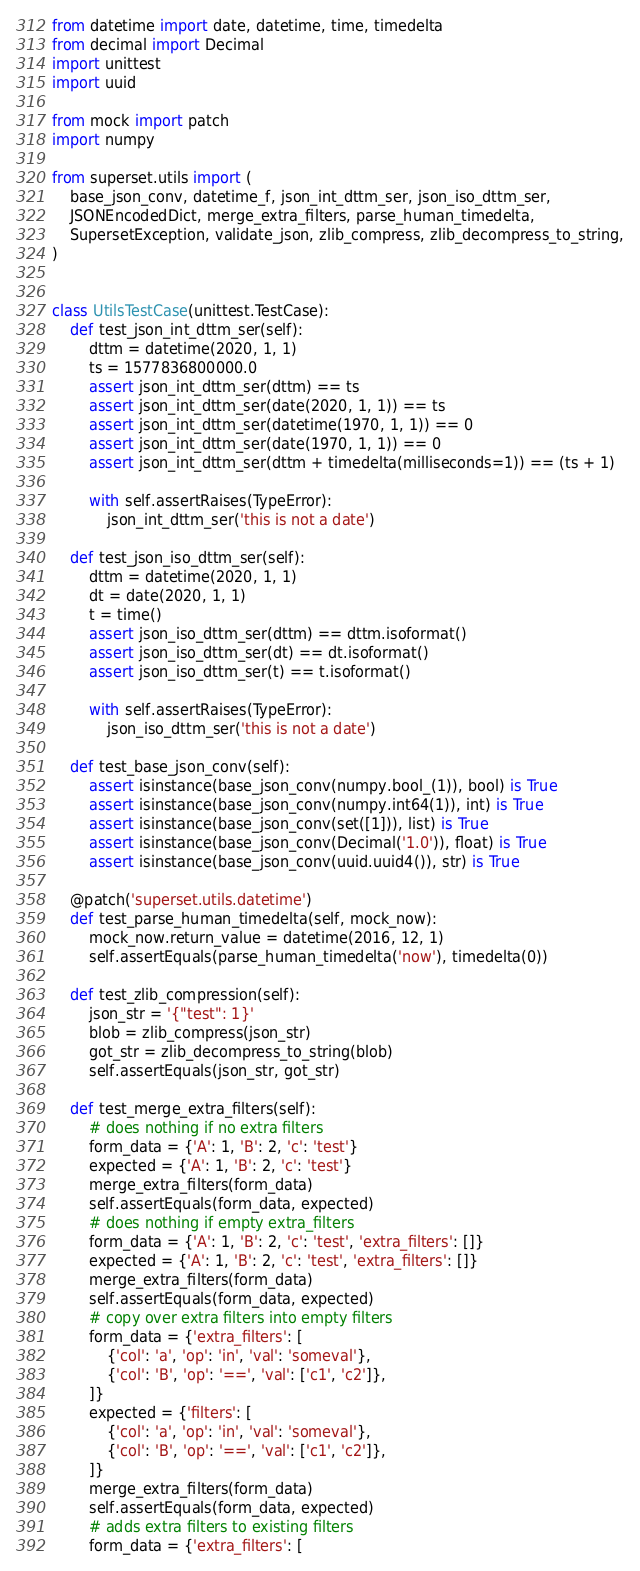Convert code to text. <code><loc_0><loc_0><loc_500><loc_500><_Python_>from datetime import date, datetime, time, timedelta
from decimal import Decimal
import unittest
import uuid

from mock import patch
import numpy

from superset.utils import (
    base_json_conv, datetime_f, json_int_dttm_ser, json_iso_dttm_ser,
    JSONEncodedDict, merge_extra_filters, parse_human_timedelta,
    SupersetException, validate_json, zlib_compress, zlib_decompress_to_string,
)


class UtilsTestCase(unittest.TestCase):
    def test_json_int_dttm_ser(self):
        dttm = datetime(2020, 1, 1)
        ts = 1577836800000.0
        assert json_int_dttm_ser(dttm) == ts
        assert json_int_dttm_ser(date(2020, 1, 1)) == ts
        assert json_int_dttm_ser(datetime(1970, 1, 1)) == 0
        assert json_int_dttm_ser(date(1970, 1, 1)) == 0
        assert json_int_dttm_ser(dttm + timedelta(milliseconds=1)) == (ts + 1)

        with self.assertRaises(TypeError):
            json_int_dttm_ser('this is not a date')

    def test_json_iso_dttm_ser(self):
        dttm = datetime(2020, 1, 1)
        dt = date(2020, 1, 1)
        t = time()
        assert json_iso_dttm_ser(dttm) == dttm.isoformat()
        assert json_iso_dttm_ser(dt) == dt.isoformat()
        assert json_iso_dttm_ser(t) == t.isoformat()

        with self.assertRaises(TypeError):
            json_iso_dttm_ser('this is not a date')

    def test_base_json_conv(self):
        assert isinstance(base_json_conv(numpy.bool_(1)), bool) is True
        assert isinstance(base_json_conv(numpy.int64(1)), int) is True
        assert isinstance(base_json_conv(set([1])), list) is True
        assert isinstance(base_json_conv(Decimal('1.0')), float) is True
        assert isinstance(base_json_conv(uuid.uuid4()), str) is True

    @patch('superset.utils.datetime')
    def test_parse_human_timedelta(self, mock_now):
        mock_now.return_value = datetime(2016, 12, 1)
        self.assertEquals(parse_human_timedelta('now'), timedelta(0))

    def test_zlib_compression(self):
        json_str = '{"test": 1}'
        blob = zlib_compress(json_str)
        got_str = zlib_decompress_to_string(blob)
        self.assertEquals(json_str, got_str)

    def test_merge_extra_filters(self):
        # does nothing if no extra filters
        form_data = {'A': 1, 'B': 2, 'c': 'test'}
        expected = {'A': 1, 'B': 2, 'c': 'test'}
        merge_extra_filters(form_data)
        self.assertEquals(form_data, expected)
        # does nothing if empty extra_filters
        form_data = {'A': 1, 'B': 2, 'c': 'test', 'extra_filters': []}
        expected = {'A': 1, 'B': 2, 'c': 'test', 'extra_filters': []}
        merge_extra_filters(form_data)
        self.assertEquals(form_data, expected)
        # copy over extra filters into empty filters
        form_data = {'extra_filters': [
            {'col': 'a', 'op': 'in', 'val': 'someval'},
            {'col': 'B', 'op': '==', 'val': ['c1', 'c2']},
        ]}
        expected = {'filters': [
            {'col': 'a', 'op': 'in', 'val': 'someval'},
            {'col': 'B', 'op': '==', 'val': ['c1', 'c2']},
        ]}
        merge_extra_filters(form_data)
        self.assertEquals(form_data, expected)
        # adds extra filters to existing filters
        form_data = {'extra_filters': [</code> 